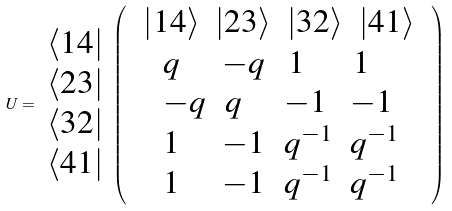<formula> <loc_0><loc_0><loc_500><loc_500>U = \begin{array} { l } \left \langle 1 4 \right | \\ \left \langle 2 3 \right | \\ \left \langle 3 2 \right | \\ \left \langle 4 1 \right | \end{array} \left ( \begin{array} { c } \begin{array} { l l l l } \left | 1 4 \right \rangle & \left | 2 3 \right \rangle & \left | 3 2 \right \rangle & \left | 4 1 \right \rangle \end{array} \\ \, \begin{array} { l l l l } q \, & - q \, & \, 1 \, & \, 1 \\ - q & \, q \, & - 1 \, & - 1 \\ 1 & - 1 & q ^ { - 1 } & q ^ { - 1 } \\ 1 & - 1 & q ^ { - 1 } & q ^ { - 1 } \end{array} \end{array} \right )</formula> 